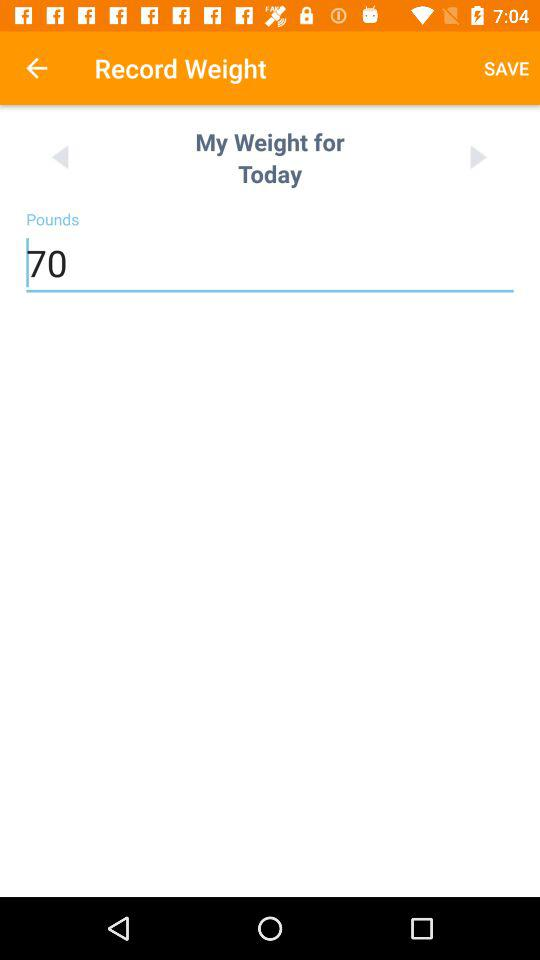What is my weight today? My weight is 70 pounds. 